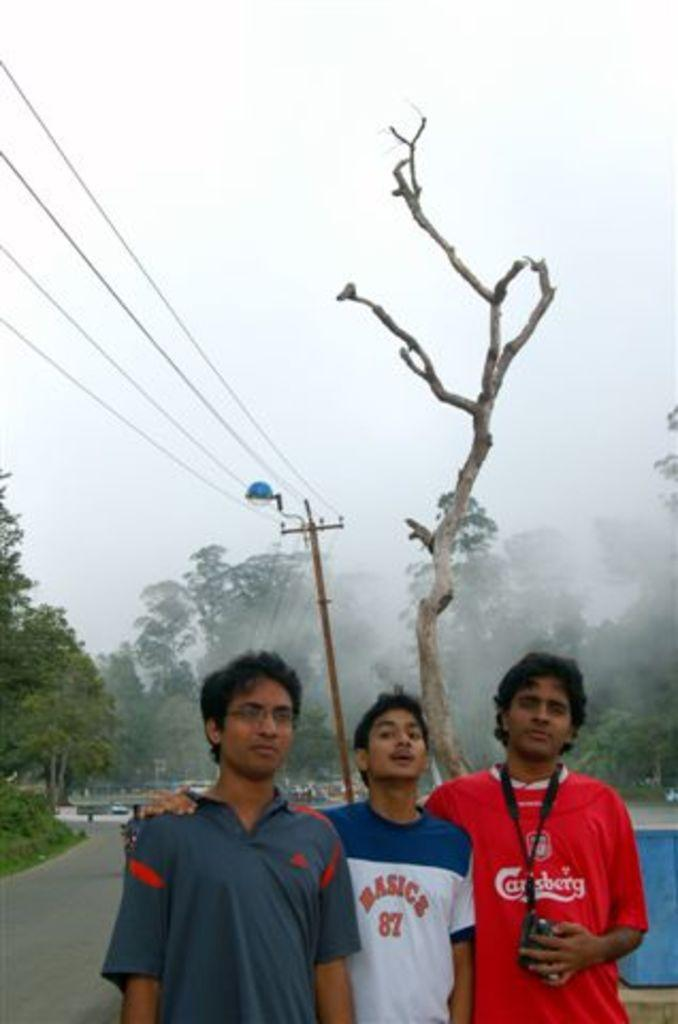<image>
Share a concise interpretation of the image provided. Three boys in front of a tree, one has 87 on his shirt. 